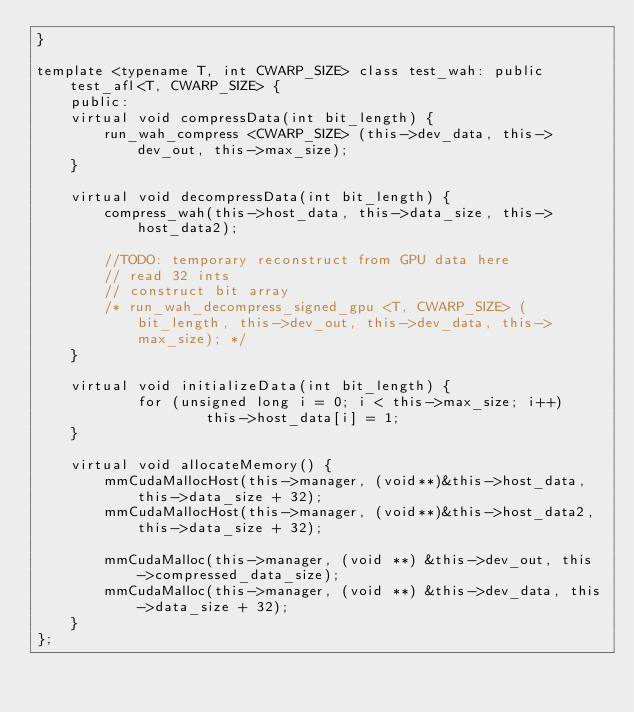<code> <loc_0><loc_0><loc_500><loc_500><_Cuda_>}

template <typename T, int CWARP_SIZE> class test_wah: public test_afl<T, CWARP_SIZE> {
    public:
    virtual void compressData(int bit_length) {
        run_wah_compress <CWARP_SIZE> (this->dev_data, this->dev_out, this->max_size);
    }

    virtual void decompressData(int bit_length) {
        compress_wah(this->host_data, this->data_size, this->host_data2);

        //TODO: temporary reconstruct from GPU data here
        // read 32 ints
        // construct bit array
        /* run_wah_decompress_signed_gpu <T, CWARP_SIZE> (bit_length, this->dev_out, this->dev_data, this->max_size); */
    }

    virtual void initializeData(int bit_length) {
            for (unsigned long i = 0; i < this->max_size; i++)
                    this->host_data[i] = 1;
    }

    virtual void allocateMemory() {
        mmCudaMallocHost(this->manager, (void**)&this->host_data,  this->data_size + 32);
        mmCudaMallocHost(this->manager, (void**)&this->host_data2, this->data_size + 32);

        mmCudaMalloc(this->manager, (void **) &this->dev_out, this->compressed_data_size);
        mmCudaMalloc(this->manager, (void **) &this->dev_data, this->data_size + 32);
    }
};
</code> 